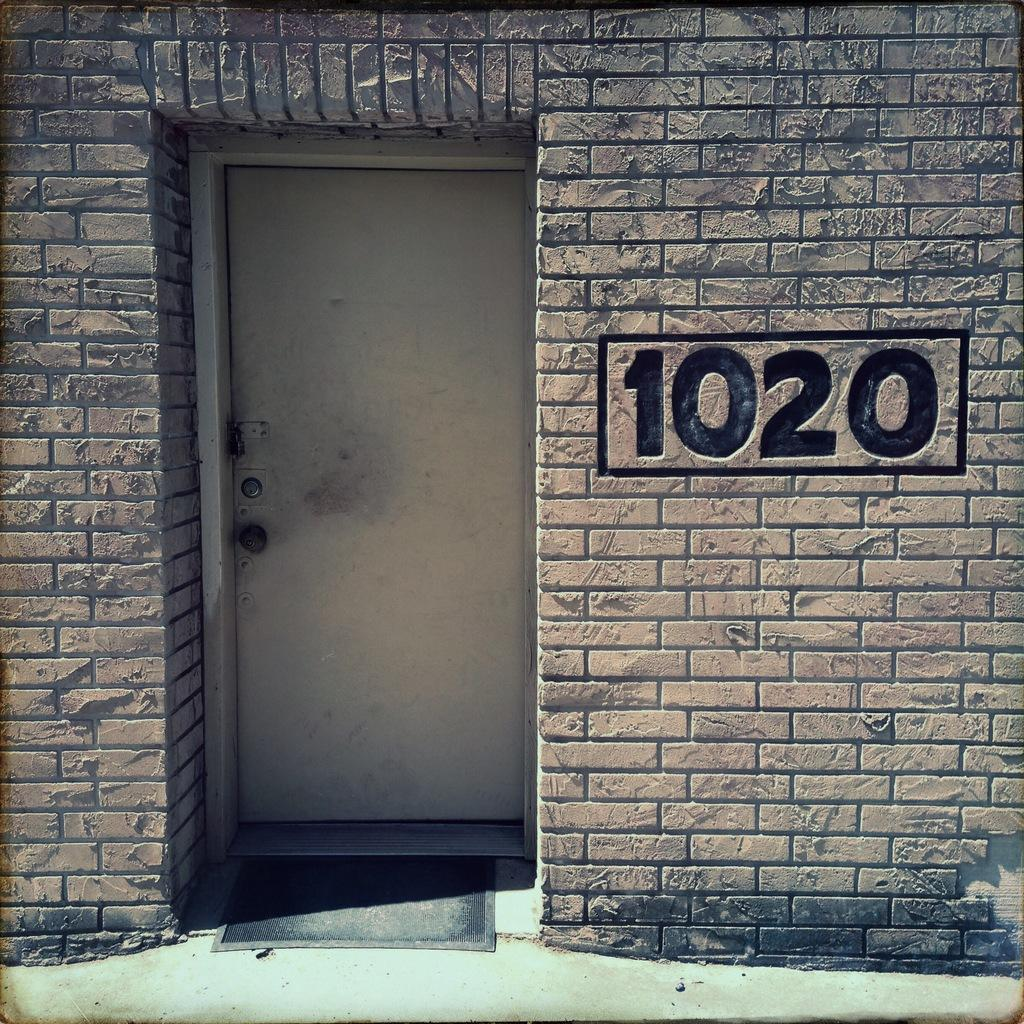What type of image is this? The image is an edited picture. What can be seen in the background of the image? There is a building in the image. What is written or displayed on the building? There is text on the wall of the building. What is located in the foreground of the image? There is a door in the foreground of the image. What is on the floor at the bottom of the image? There is a mat on the floor at the bottom of the image. What type of notebook is placed near the volcano in the image? There is no notebook or volcano present in the image. What is the level of interest in the image? The level of interest in the image cannot be determined based on the provided facts. 